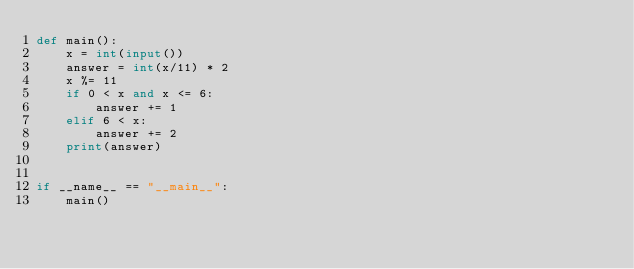<code> <loc_0><loc_0><loc_500><loc_500><_Python_>def main():
    x = int(input())
    answer = int(x/11) * 2
    x %= 11
    if 0 < x and x <= 6:
        answer += 1
    elif 6 < x:
        answer += 2
    print(answer)


if __name__ == "__main__":
    main()
</code> 